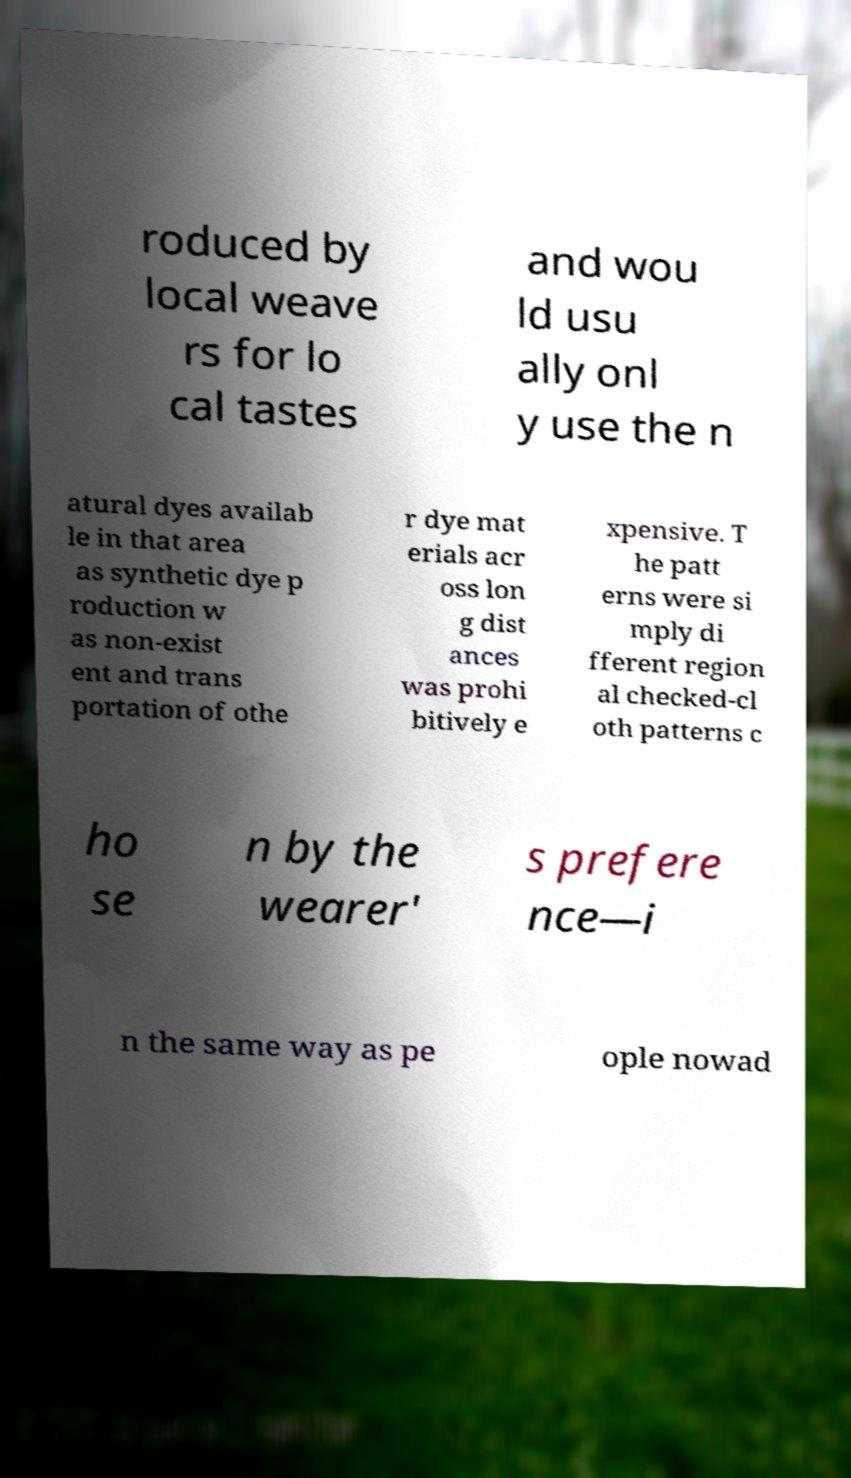There's text embedded in this image that I need extracted. Can you transcribe it verbatim? roduced by local weave rs for lo cal tastes and wou ld usu ally onl y use the n atural dyes availab le in that area as synthetic dye p roduction w as non-exist ent and trans portation of othe r dye mat erials acr oss lon g dist ances was prohi bitively e xpensive. T he patt erns were si mply di fferent region al checked-cl oth patterns c ho se n by the wearer' s prefere nce—i n the same way as pe ople nowad 